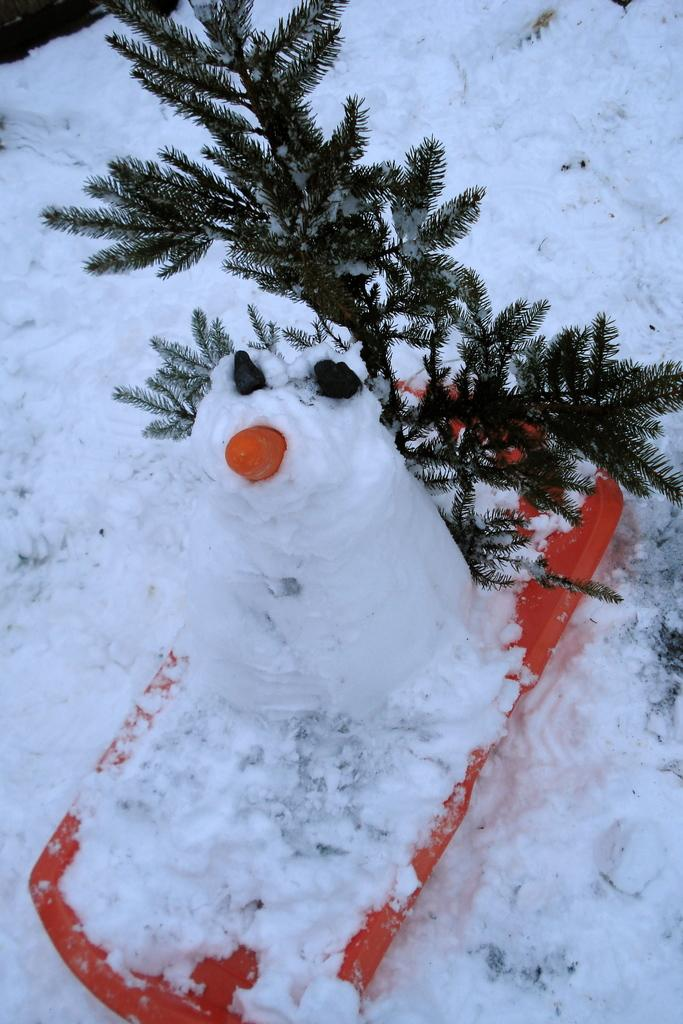What type of doll is in the image? There is a snow doll in the image. What is the weather or season suggested by the presence of snow in the image? The presence of snow suggests a winter season or cold weather. What type of plant is represented by the leaves in the image? The leaves in the image belong to an unspecified plant. Can you describe the unspecified object in the image? Unfortunately, the facts provided do not give enough information to describe the unspecified object in the image. What type of secretary is sitting behind the snow doll in the image? There is no secretary present in the image; it only features a snow doll and other unspecified elements. 